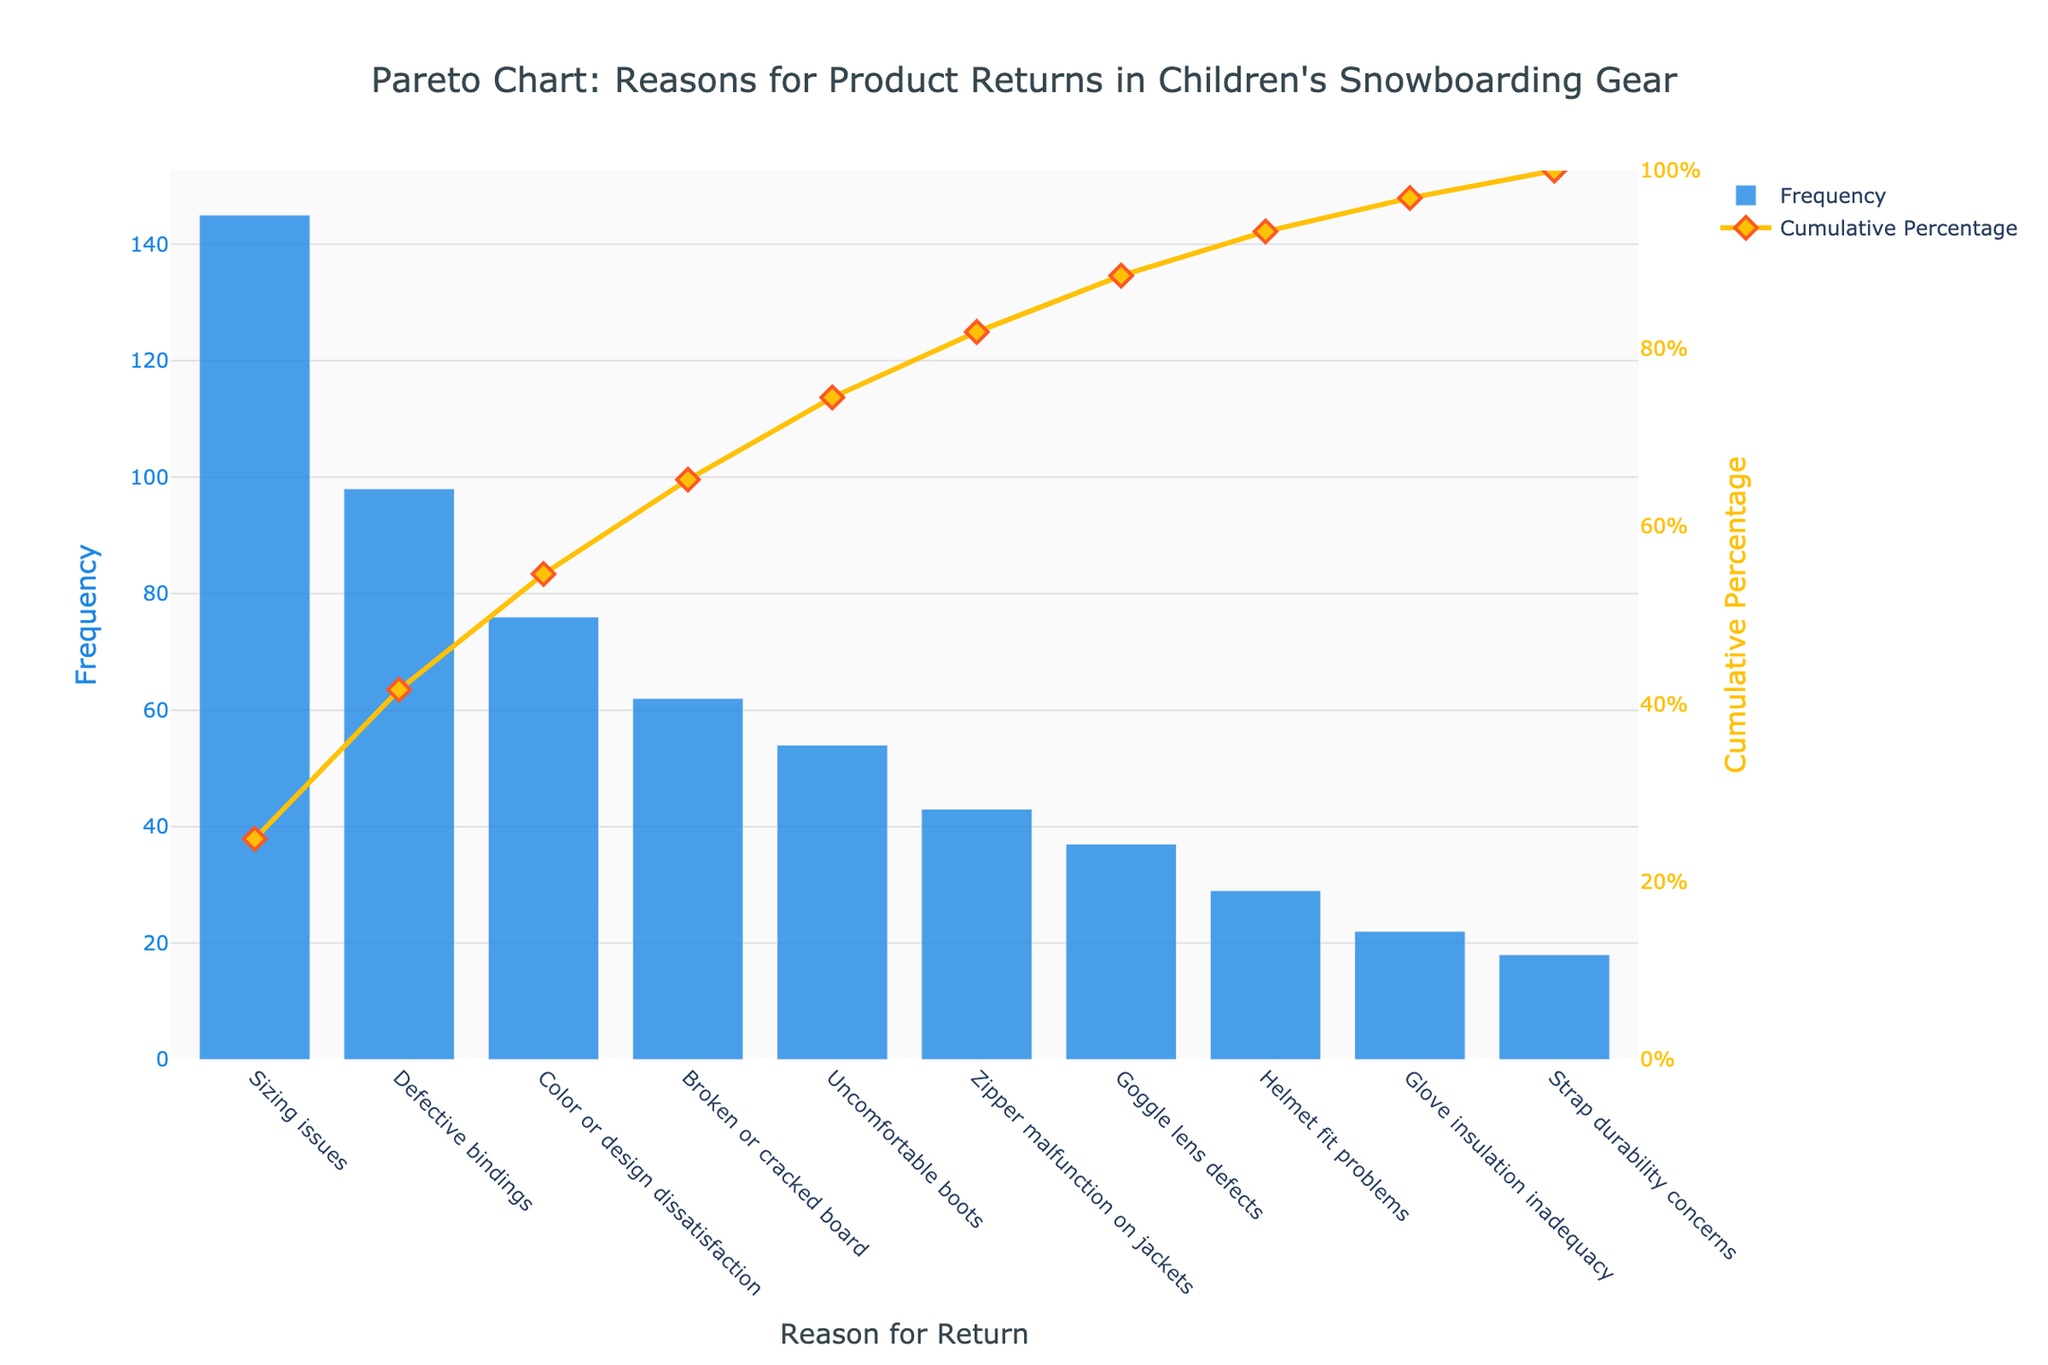What is the title of the chart? The title can be found at the top center of the figure. It reads "Pareto Chart: Reasons for Product Returns in Children's Snowboarding Gear".
Answer: Pareto Chart: Reasons for Product Returns in Children's Snowboarding Gear Which category has the highest frequency of product returns? The category with the highest frequency is represented by the tallest bar in the chart. The tallest bar corresponds to "Sizing issues".
Answer: Sizing issues What's the cumulative percentage after including the top three reasons for returns? The cumulative percentage is shown by the line plot. At the third category (Color or design dissatisfaction), the cumulative percentage is approximately 75%.
Answer: 75% How many categories account for at least 80% of the product returns? The cumulative percentage needs to reach 80%. By following the data points along the cumulative percentage line, it is evident that the first four categories (Sizing issues, Defective bindings, Color or design dissatisfaction, Broken or cracked board) account for at least 80% of returns.
Answer: 4 What's the frequency of returns due to uncomfortable boots? The frequency of returns can be directly read from the height of the bar corresponding to "Uncomfortable boots", which shows a frequency of 54.
Answer: 54 Are returns due to helmet fit problems more or less frequent than returns due to goggle lens defects? By how much? The frequency of "Helmet fit problems" is 29, while "Goggle lens defects" is 37. The difference is calculated as 37 - 29 which equals 8.
Answer: Less by 8 What color represents the frequency bars in the chart? The color of the frequency bars can be identified visually in the figure. They are in a shade of blue.
Answer: Blue What is the cumulative percentage for the reason "Broken or cracked board"? The cumulative percentage for "Broken or cracked board" can be seen on the line plot, which is just below 80%.
Answer: Just below 80% Which return reason has the lowest frequency, and what is it? The shortest bar on the chart represents the lowest frequency, which corresponds to "Strap durability concerns" with a frequency of 18.
Answer: Strap durability concerns, 18 